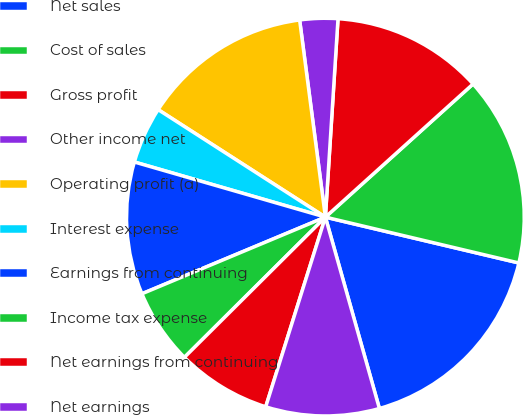Convert chart. <chart><loc_0><loc_0><loc_500><loc_500><pie_chart><fcel>Net sales<fcel>Cost of sales<fcel>Gross profit<fcel>Other income net<fcel>Operating profit (a)<fcel>Interest expense<fcel>Earnings from continuing<fcel>Income tax expense<fcel>Net earnings from continuing<fcel>Net earnings<nl><fcel>16.92%<fcel>15.38%<fcel>12.31%<fcel>3.08%<fcel>13.84%<fcel>4.62%<fcel>10.77%<fcel>6.16%<fcel>7.69%<fcel>9.23%<nl></chart> 